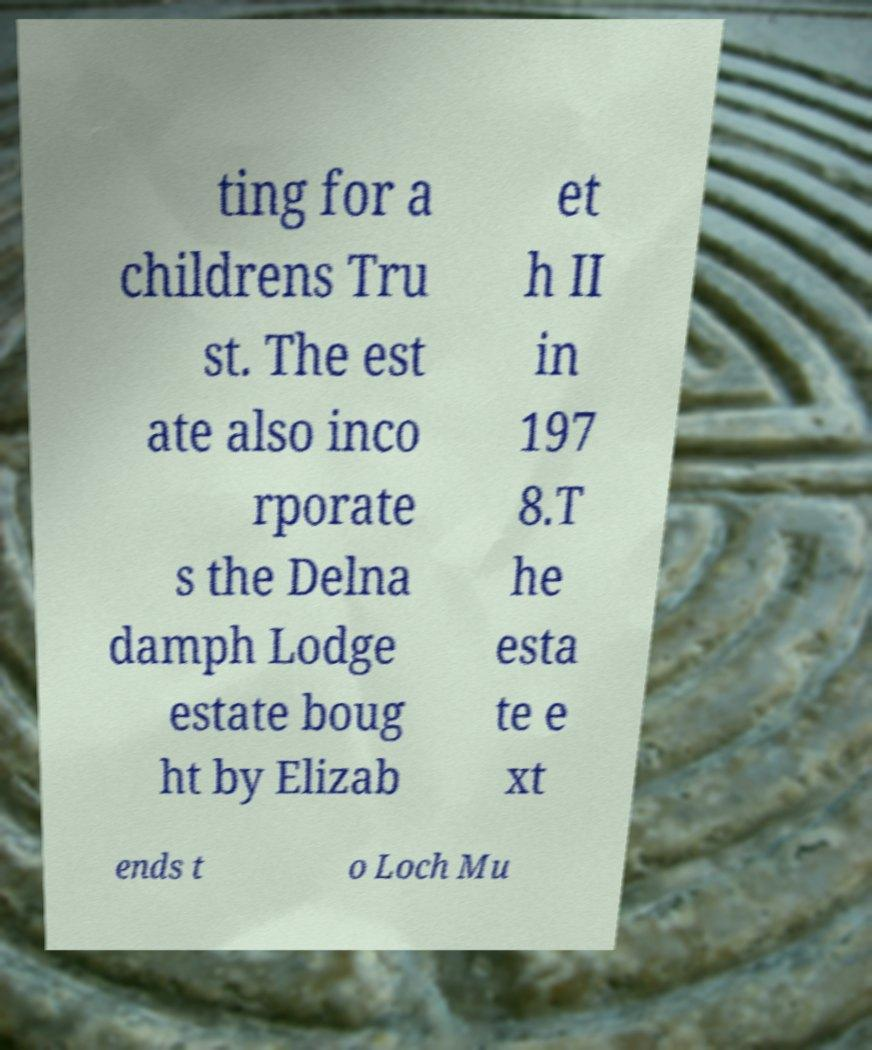I need the written content from this picture converted into text. Can you do that? ting for a childrens Tru st. The est ate also inco rporate s the Delna damph Lodge estate boug ht by Elizab et h II in 197 8.T he esta te e xt ends t o Loch Mu 